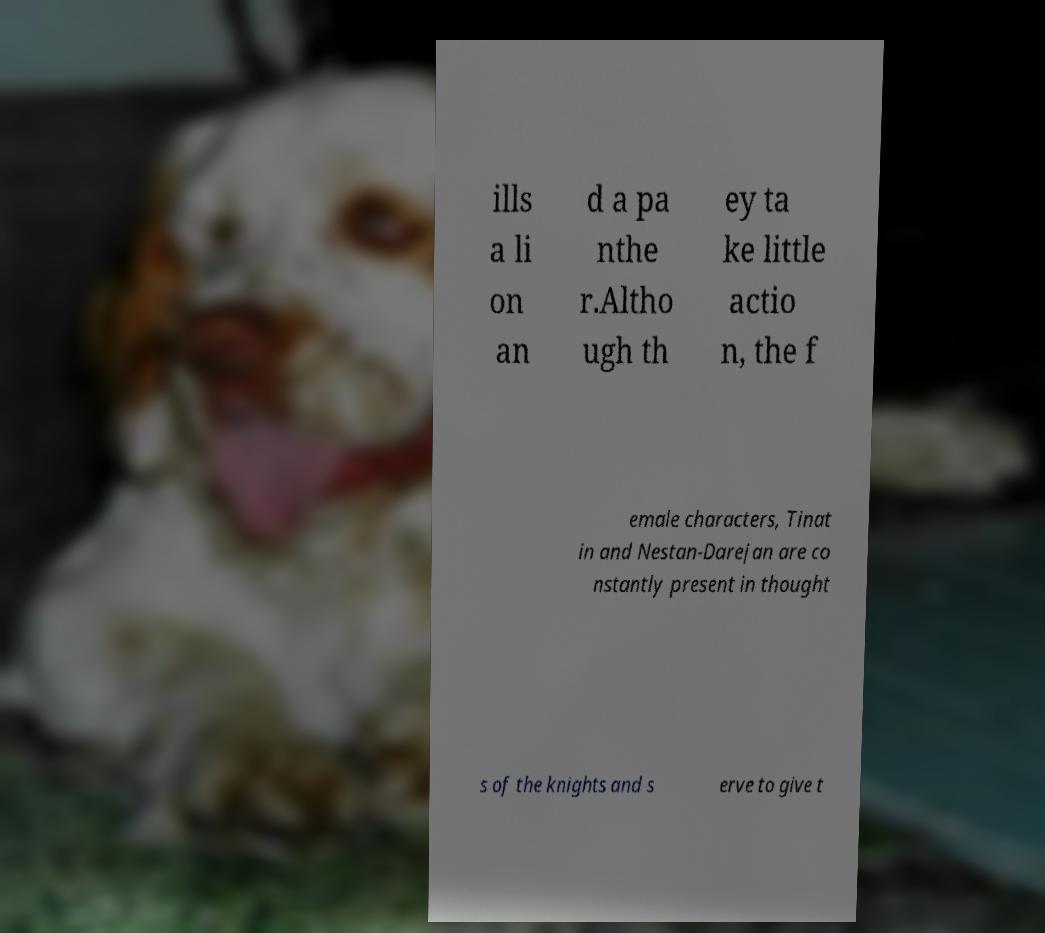I need the written content from this picture converted into text. Can you do that? ills a li on an d a pa nthe r.Altho ugh th ey ta ke little actio n, the f emale characters, Tinat in and Nestan-Darejan are co nstantly present in thought s of the knights and s erve to give t 